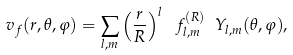Convert formula to latex. <formula><loc_0><loc_0><loc_500><loc_500>v _ { f } ( r , \theta , \varphi ) = \sum _ { l , m } \left ( \frac { r } { R } \right ) ^ { l } \ f _ { l , m } ^ { ( R ) } \ Y _ { l , m } ( \theta , \varphi ) ,</formula> 